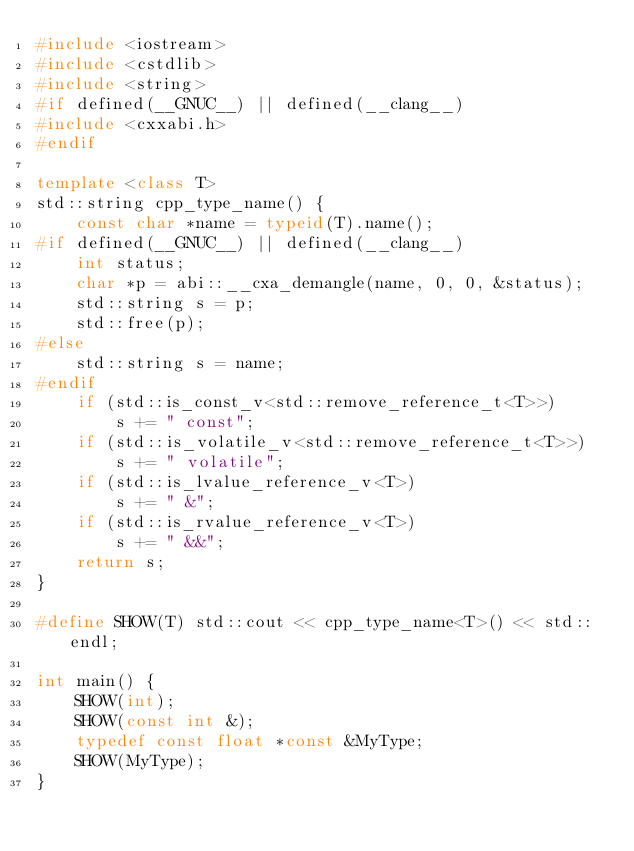<code> <loc_0><loc_0><loc_500><loc_500><_C++_>#include <iostream>
#include <cstdlib>
#include <string>
#if defined(__GNUC__) || defined(__clang__)
#include <cxxabi.h>
#endif

template <class T>
std::string cpp_type_name() {
    const char *name = typeid(T).name();
#if defined(__GNUC__) || defined(__clang__)
    int status;
    char *p = abi::__cxa_demangle(name, 0, 0, &status);
    std::string s = p;
    std::free(p);
#else
    std::string s = name;
#endif
    if (std::is_const_v<std::remove_reference_t<T>>)
        s += " const";
    if (std::is_volatile_v<std::remove_reference_t<T>>)
        s += " volatile";
    if (std::is_lvalue_reference_v<T>)
        s += " &";
    if (std::is_rvalue_reference_v<T>)
        s += " &&";
    return s;
}

#define SHOW(T) std::cout << cpp_type_name<T>() << std::endl;

int main() {
    SHOW(int);
    SHOW(const int &);
    typedef const float *const &MyType;
    SHOW(MyType);
}
</code> 